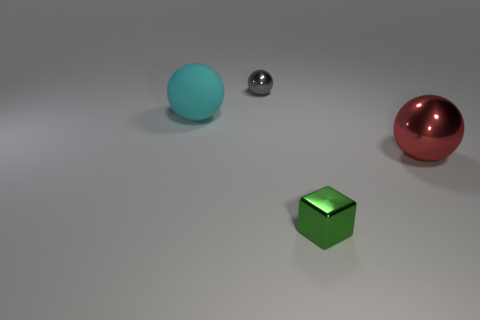Add 2 small green shiny blocks. How many objects exist? 6 Subtract all cubes. How many objects are left? 3 Subtract all red metal objects. Subtract all large cyan objects. How many objects are left? 2 Add 4 tiny blocks. How many tiny blocks are left? 5 Add 3 green things. How many green things exist? 4 Subtract 0 gray cylinders. How many objects are left? 4 